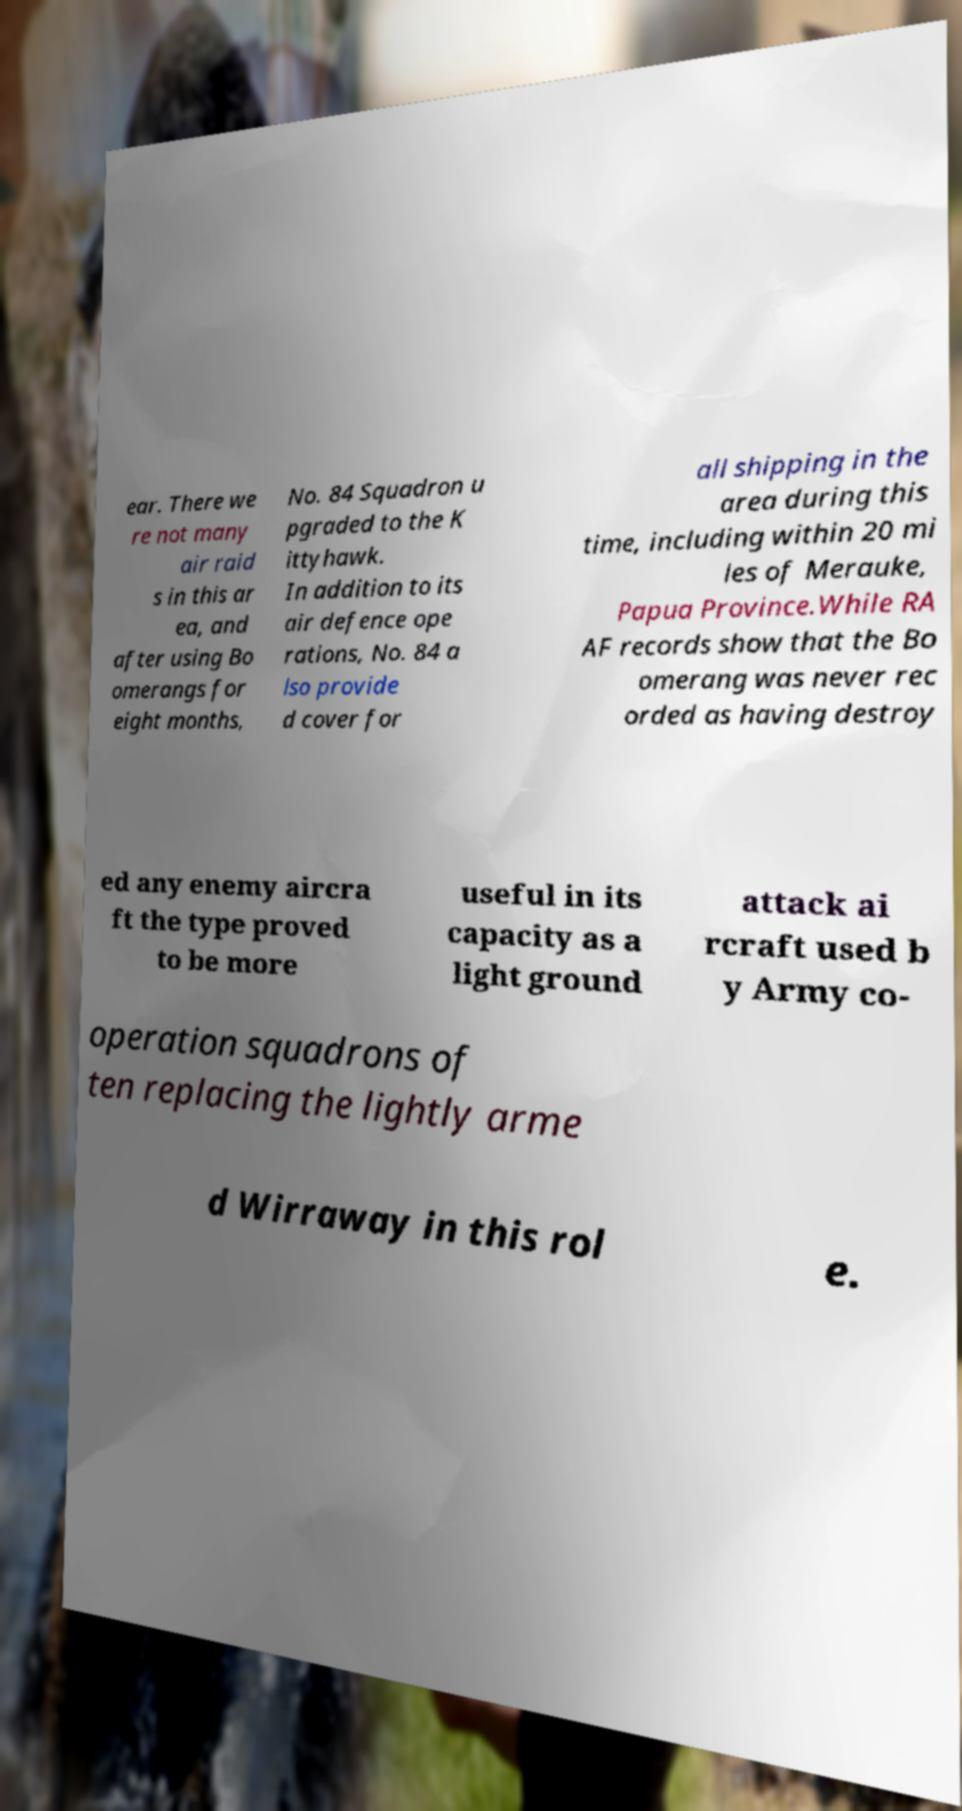There's text embedded in this image that I need extracted. Can you transcribe it verbatim? ear. There we re not many air raid s in this ar ea, and after using Bo omerangs for eight months, No. 84 Squadron u pgraded to the K ittyhawk. In addition to its air defence ope rations, No. 84 a lso provide d cover for all shipping in the area during this time, including within 20 mi les of Merauke, Papua Province.While RA AF records show that the Bo omerang was never rec orded as having destroy ed any enemy aircra ft the type proved to be more useful in its capacity as a light ground attack ai rcraft used b y Army co- operation squadrons of ten replacing the lightly arme d Wirraway in this rol e. 